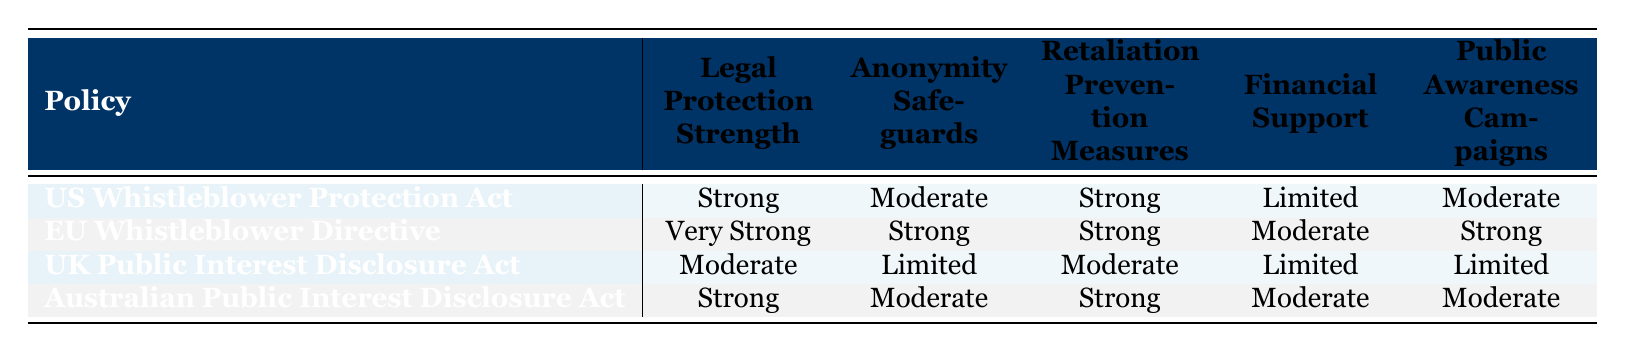What is the legal protection strength of the European Union Whistleblower Directive? The table shows that the legal protection strength for the European Union Whistleblower Directive is rated as "Very Strong."
Answer: Very Strong Which whistleblower protection policy has the strongest anonymity safeguards? According to the table, the European Union Whistleblower Directive has "Strong" anonymity safeguards, making it the policy with the strongest level of anonymity protection.
Answer: European Union Whistleblower Directive Is financial support offered under the United Kingdom Public Interest Disclosure Act limited? The evaluation shows "Limited" as the financial support under the UK Public Interest Disclosure Act, confirming the statement is true.
Answer: Yes How does the retaliation prevention measure of the US Whistleblower Protection Act compare to that of the Australian Public Interest Disclosure Act? The US Whistleblower Protection Act has a "Strong" rating for retaliation prevention measures, while the Australian Public Interest Disclosure Act also rates "Strong." Both provide the same level of protection in this aspect.
Answer: They are the same (Strong) What is the average level of financial support across all listed whistleblower protection policies? Summing up the evaluations: (Limited + Moderate + Limited + Moderate) translates to numerical values of 1 (Limited) and 2 (Moderate); hence, for four policies, the financial support value is (1 + 2 + 1 + 2) = 6/4 = 1.5, which leads to an average of 1.5. Since this is not directly on the scale described, you could classify it as a value between "Limited" and "Moderate."
Answer: Between Limited and Moderate 